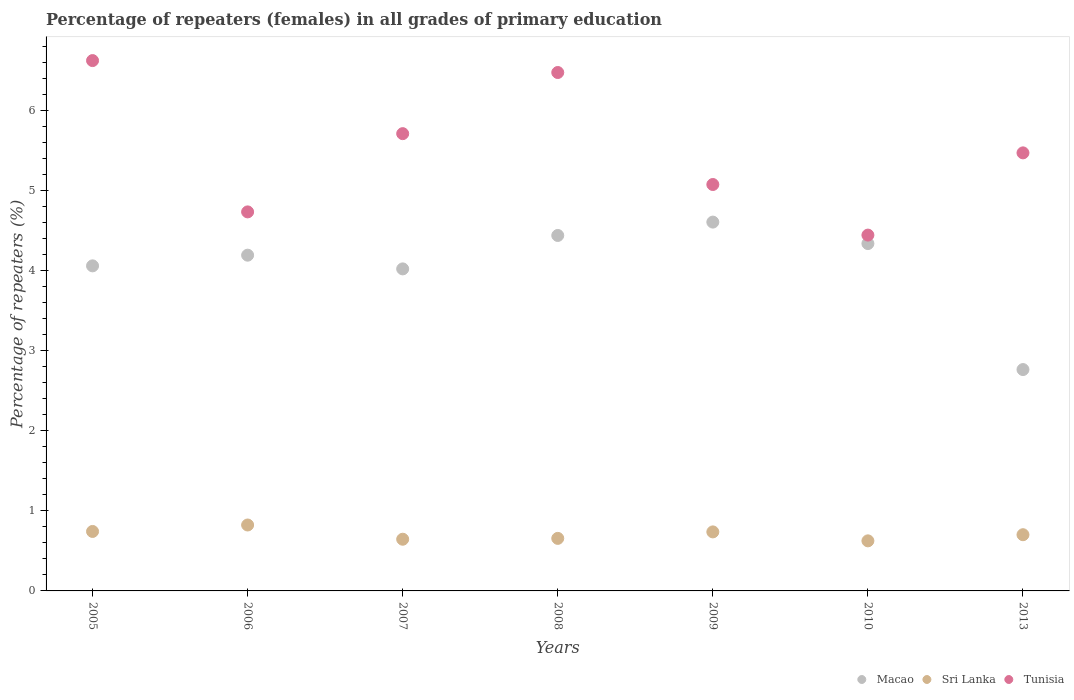Is the number of dotlines equal to the number of legend labels?
Make the answer very short. Yes. What is the percentage of repeaters (females) in Macao in 2010?
Keep it short and to the point. 4.34. Across all years, what is the maximum percentage of repeaters (females) in Tunisia?
Your answer should be very brief. 6.62. Across all years, what is the minimum percentage of repeaters (females) in Sri Lanka?
Your response must be concise. 0.63. In which year was the percentage of repeaters (females) in Tunisia minimum?
Give a very brief answer. 2010. What is the total percentage of repeaters (females) in Macao in the graph?
Offer a very short reply. 28.41. What is the difference between the percentage of repeaters (females) in Sri Lanka in 2005 and that in 2013?
Provide a succinct answer. 0.04. What is the difference between the percentage of repeaters (females) in Tunisia in 2013 and the percentage of repeaters (females) in Sri Lanka in 2007?
Your answer should be very brief. 4.82. What is the average percentage of repeaters (females) in Macao per year?
Keep it short and to the point. 4.06. In the year 2013, what is the difference between the percentage of repeaters (females) in Sri Lanka and percentage of repeaters (females) in Macao?
Your answer should be compact. -2.06. What is the ratio of the percentage of repeaters (females) in Sri Lanka in 2005 to that in 2009?
Provide a succinct answer. 1.01. What is the difference between the highest and the second highest percentage of repeaters (females) in Sri Lanka?
Your answer should be very brief. 0.08. What is the difference between the highest and the lowest percentage of repeaters (females) in Macao?
Give a very brief answer. 1.84. Is the sum of the percentage of repeaters (females) in Sri Lanka in 2006 and 2013 greater than the maximum percentage of repeaters (females) in Tunisia across all years?
Provide a short and direct response. No. Is it the case that in every year, the sum of the percentage of repeaters (females) in Sri Lanka and percentage of repeaters (females) in Macao  is greater than the percentage of repeaters (females) in Tunisia?
Offer a terse response. No. Does the percentage of repeaters (females) in Sri Lanka monotonically increase over the years?
Your answer should be very brief. No. Is the percentage of repeaters (females) in Macao strictly less than the percentage of repeaters (females) in Sri Lanka over the years?
Your response must be concise. No. How many years are there in the graph?
Keep it short and to the point. 7. What is the difference between two consecutive major ticks on the Y-axis?
Make the answer very short. 1. Are the values on the major ticks of Y-axis written in scientific E-notation?
Offer a very short reply. No. Does the graph contain any zero values?
Offer a terse response. No. Where does the legend appear in the graph?
Make the answer very short. Bottom right. How many legend labels are there?
Provide a succinct answer. 3. How are the legend labels stacked?
Keep it short and to the point. Horizontal. What is the title of the graph?
Offer a very short reply. Percentage of repeaters (females) in all grades of primary education. What is the label or title of the Y-axis?
Make the answer very short. Percentage of repeaters (%). What is the Percentage of repeaters (%) of Macao in 2005?
Your answer should be very brief. 4.06. What is the Percentage of repeaters (%) of Sri Lanka in 2005?
Give a very brief answer. 0.74. What is the Percentage of repeaters (%) of Tunisia in 2005?
Your answer should be very brief. 6.62. What is the Percentage of repeaters (%) of Macao in 2006?
Your answer should be very brief. 4.19. What is the Percentage of repeaters (%) in Sri Lanka in 2006?
Give a very brief answer. 0.82. What is the Percentage of repeaters (%) of Tunisia in 2006?
Your answer should be very brief. 4.73. What is the Percentage of repeaters (%) of Macao in 2007?
Give a very brief answer. 4.02. What is the Percentage of repeaters (%) in Sri Lanka in 2007?
Provide a succinct answer. 0.65. What is the Percentage of repeaters (%) of Tunisia in 2007?
Your response must be concise. 5.71. What is the Percentage of repeaters (%) of Macao in 2008?
Keep it short and to the point. 4.44. What is the Percentage of repeaters (%) in Sri Lanka in 2008?
Ensure brevity in your answer.  0.66. What is the Percentage of repeaters (%) in Tunisia in 2008?
Your response must be concise. 6.47. What is the Percentage of repeaters (%) in Macao in 2009?
Keep it short and to the point. 4.6. What is the Percentage of repeaters (%) of Sri Lanka in 2009?
Offer a very short reply. 0.74. What is the Percentage of repeaters (%) in Tunisia in 2009?
Offer a terse response. 5.07. What is the Percentage of repeaters (%) in Macao in 2010?
Your answer should be compact. 4.34. What is the Percentage of repeaters (%) of Sri Lanka in 2010?
Offer a terse response. 0.63. What is the Percentage of repeaters (%) of Tunisia in 2010?
Offer a terse response. 4.44. What is the Percentage of repeaters (%) in Macao in 2013?
Offer a very short reply. 2.76. What is the Percentage of repeaters (%) of Sri Lanka in 2013?
Your answer should be very brief. 0.7. What is the Percentage of repeaters (%) in Tunisia in 2013?
Provide a short and direct response. 5.47. Across all years, what is the maximum Percentage of repeaters (%) of Macao?
Your answer should be compact. 4.6. Across all years, what is the maximum Percentage of repeaters (%) in Sri Lanka?
Keep it short and to the point. 0.82. Across all years, what is the maximum Percentage of repeaters (%) of Tunisia?
Offer a very short reply. 6.62. Across all years, what is the minimum Percentage of repeaters (%) in Macao?
Provide a short and direct response. 2.76. Across all years, what is the minimum Percentage of repeaters (%) in Sri Lanka?
Give a very brief answer. 0.63. Across all years, what is the minimum Percentage of repeaters (%) of Tunisia?
Your response must be concise. 4.44. What is the total Percentage of repeaters (%) of Macao in the graph?
Make the answer very short. 28.41. What is the total Percentage of repeaters (%) of Sri Lanka in the graph?
Your response must be concise. 4.93. What is the total Percentage of repeaters (%) in Tunisia in the graph?
Provide a succinct answer. 38.52. What is the difference between the Percentage of repeaters (%) of Macao in 2005 and that in 2006?
Make the answer very short. -0.13. What is the difference between the Percentage of repeaters (%) of Sri Lanka in 2005 and that in 2006?
Offer a very short reply. -0.08. What is the difference between the Percentage of repeaters (%) in Tunisia in 2005 and that in 2006?
Your answer should be very brief. 1.89. What is the difference between the Percentage of repeaters (%) of Macao in 2005 and that in 2007?
Offer a very short reply. 0.04. What is the difference between the Percentage of repeaters (%) of Sri Lanka in 2005 and that in 2007?
Give a very brief answer. 0.1. What is the difference between the Percentage of repeaters (%) in Tunisia in 2005 and that in 2007?
Offer a terse response. 0.91. What is the difference between the Percentage of repeaters (%) of Macao in 2005 and that in 2008?
Your answer should be very brief. -0.38. What is the difference between the Percentage of repeaters (%) of Sri Lanka in 2005 and that in 2008?
Offer a terse response. 0.09. What is the difference between the Percentage of repeaters (%) in Tunisia in 2005 and that in 2008?
Your answer should be very brief. 0.15. What is the difference between the Percentage of repeaters (%) of Macao in 2005 and that in 2009?
Offer a terse response. -0.55. What is the difference between the Percentage of repeaters (%) of Sri Lanka in 2005 and that in 2009?
Your response must be concise. 0.01. What is the difference between the Percentage of repeaters (%) in Tunisia in 2005 and that in 2009?
Make the answer very short. 1.55. What is the difference between the Percentage of repeaters (%) in Macao in 2005 and that in 2010?
Your answer should be very brief. -0.28. What is the difference between the Percentage of repeaters (%) in Sri Lanka in 2005 and that in 2010?
Offer a terse response. 0.12. What is the difference between the Percentage of repeaters (%) of Tunisia in 2005 and that in 2010?
Your answer should be compact. 2.18. What is the difference between the Percentage of repeaters (%) of Macao in 2005 and that in 2013?
Provide a succinct answer. 1.29. What is the difference between the Percentage of repeaters (%) of Sri Lanka in 2005 and that in 2013?
Give a very brief answer. 0.04. What is the difference between the Percentage of repeaters (%) of Tunisia in 2005 and that in 2013?
Keep it short and to the point. 1.15. What is the difference between the Percentage of repeaters (%) of Macao in 2006 and that in 2007?
Your answer should be very brief. 0.17. What is the difference between the Percentage of repeaters (%) in Sri Lanka in 2006 and that in 2007?
Provide a succinct answer. 0.18. What is the difference between the Percentage of repeaters (%) in Tunisia in 2006 and that in 2007?
Offer a very short reply. -0.98. What is the difference between the Percentage of repeaters (%) in Macao in 2006 and that in 2008?
Ensure brevity in your answer.  -0.25. What is the difference between the Percentage of repeaters (%) of Sri Lanka in 2006 and that in 2008?
Provide a short and direct response. 0.17. What is the difference between the Percentage of repeaters (%) in Tunisia in 2006 and that in 2008?
Provide a short and direct response. -1.74. What is the difference between the Percentage of repeaters (%) in Macao in 2006 and that in 2009?
Offer a very short reply. -0.41. What is the difference between the Percentage of repeaters (%) in Sri Lanka in 2006 and that in 2009?
Keep it short and to the point. 0.09. What is the difference between the Percentage of repeaters (%) of Tunisia in 2006 and that in 2009?
Give a very brief answer. -0.34. What is the difference between the Percentage of repeaters (%) of Macao in 2006 and that in 2010?
Provide a succinct answer. -0.14. What is the difference between the Percentage of repeaters (%) in Sri Lanka in 2006 and that in 2010?
Ensure brevity in your answer.  0.2. What is the difference between the Percentage of repeaters (%) of Tunisia in 2006 and that in 2010?
Ensure brevity in your answer.  0.29. What is the difference between the Percentage of repeaters (%) in Macao in 2006 and that in 2013?
Ensure brevity in your answer.  1.43. What is the difference between the Percentage of repeaters (%) in Sri Lanka in 2006 and that in 2013?
Keep it short and to the point. 0.12. What is the difference between the Percentage of repeaters (%) of Tunisia in 2006 and that in 2013?
Keep it short and to the point. -0.74. What is the difference between the Percentage of repeaters (%) of Macao in 2007 and that in 2008?
Give a very brief answer. -0.42. What is the difference between the Percentage of repeaters (%) in Sri Lanka in 2007 and that in 2008?
Your answer should be compact. -0.01. What is the difference between the Percentage of repeaters (%) of Tunisia in 2007 and that in 2008?
Ensure brevity in your answer.  -0.76. What is the difference between the Percentage of repeaters (%) in Macao in 2007 and that in 2009?
Give a very brief answer. -0.58. What is the difference between the Percentage of repeaters (%) in Sri Lanka in 2007 and that in 2009?
Offer a terse response. -0.09. What is the difference between the Percentage of repeaters (%) in Tunisia in 2007 and that in 2009?
Your response must be concise. 0.63. What is the difference between the Percentage of repeaters (%) in Macao in 2007 and that in 2010?
Make the answer very short. -0.32. What is the difference between the Percentage of repeaters (%) in Sri Lanka in 2007 and that in 2010?
Provide a short and direct response. 0.02. What is the difference between the Percentage of repeaters (%) of Tunisia in 2007 and that in 2010?
Make the answer very short. 1.27. What is the difference between the Percentage of repeaters (%) of Macao in 2007 and that in 2013?
Provide a succinct answer. 1.26. What is the difference between the Percentage of repeaters (%) of Sri Lanka in 2007 and that in 2013?
Your response must be concise. -0.06. What is the difference between the Percentage of repeaters (%) of Tunisia in 2007 and that in 2013?
Ensure brevity in your answer.  0.24. What is the difference between the Percentage of repeaters (%) in Macao in 2008 and that in 2009?
Keep it short and to the point. -0.17. What is the difference between the Percentage of repeaters (%) of Sri Lanka in 2008 and that in 2009?
Provide a short and direct response. -0.08. What is the difference between the Percentage of repeaters (%) of Tunisia in 2008 and that in 2009?
Your answer should be very brief. 1.4. What is the difference between the Percentage of repeaters (%) in Macao in 2008 and that in 2010?
Keep it short and to the point. 0.1. What is the difference between the Percentage of repeaters (%) of Sri Lanka in 2008 and that in 2010?
Offer a very short reply. 0.03. What is the difference between the Percentage of repeaters (%) of Tunisia in 2008 and that in 2010?
Offer a terse response. 2.03. What is the difference between the Percentage of repeaters (%) of Macao in 2008 and that in 2013?
Provide a succinct answer. 1.67. What is the difference between the Percentage of repeaters (%) in Sri Lanka in 2008 and that in 2013?
Your response must be concise. -0.05. What is the difference between the Percentage of repeaters (%) in Macao in 2009 and that in 2010?
Your response must be concise. 0.27. What is the difference between the Percentage of repeaters (%) in Sri Lanka in 2009 and that in 2010?
Your answer should be compact. 0.11. What is the difference between the Percentage of repeaters (%) of Tunisia in 2009 and that in 2010?
Offer a very short reply. 0.63. What is the difference between the Percentage of repeaters (%) in Macao in 2009 and that in 2013?
Provide a succinct answer. 1.84. What is the difference between the Percentage of repeaters (%) in Sri Lanka in 2009 and that in 2013?
Ensure brevity in your answer.  0.04. What is the difference between the Percentage of repeaters (%) in Tunisia in 2009 and that in 2013?
Your answer should be very brief. -0.4. What is the difference between the Percentage of repeaters (%) in Macao in 2010 and that in 2013?
Provide a short and direct response. 1.57. What is the difference between the Percentage of repeaters (%) of Sri Lanka in 2010 and that in 2013?
Your answer should be very brief. -0.08. What is the difference between the Percentage of repeaters (%) in Tunisia in 2010 and that in 2013?
Keep it short and to the point. -1.03. What is the difference between the Percentage of repeaters (%) in Macao in 2005 and the Percentage of repeaters (%) in Sri Lanka in 2006?
Offer a very short reply. 3.24. What is the difference between the Percentage of repeaters (%) of Macao in 2005 and the Percentage of repeaters (%) of Tunisia in 2006?
Provide a short and direct response. -0.67. What is the difference between the Percentage of repeaters (%) of Sri Lanka in 2005 and the Percentage of repeaters (%) of Tunisia in 2006?
Make the answer very short. -3.99. What is the difference between the Percentage of repeaters (%) in Macao in 2005 and the Percentage of repeaters (%) in Sri Lanka in 2007?
Your answer should be compact. 3.41. What is the difference between the Percentage of repeaters (%) of Macao in 2005 and the Percentage of repeaters (%) of Tunisia in 2007?
Provide a succinct answer. -1.65. What is the difference between the Percentage of repeaters (%) in Sri Lanka in 2005 and the Percentage of repeaters (%) in Tunisia in 2007?
Your answer should be very brief. -4.97. What is the difference between the Percentage of repeaters (%) of Macao in 2005 and the Percentage of repeaters (%) of Sri Lanka in 2008?
Offer a very short reply. 3.4. What is the difference between the Percentage of repeaters (%) in Macao in 2005 and the Percentage of repeaters (%) in Tunisia in 2008?
Give a very brief answer. -2.41. What is the difference between the Percentage of repeaters (%) of Sri Lanka in 2005 and the Percentage of repeaters (%) of Tunisia in 2008?
Keep it short and to the point. -5.73. What is the difference between the Percentage of repeaters (%) of Macao in 2005 and the Percentage of repeaters (%) of Sri Lanka in 2009?
Ensure brevity in your answer.  3.32. What is the difference between the Percentage of repeaters (%) of Macao in 2005 and the Percentage of repeaters (%) of Tunisia in 2009?
Offer a terse response. -1.02. What is the difference between the Percentage of repeaters (%) in Sri Lanka in 2005 and the Percentage of repeaters (%) in Tunisia in 2009?
Offer a very short reply. -4.33. What is the difference between the Percentage of repeaters (%) in Macao in 2005 and the Percentage of repeaters (%) in Sri Lanka in 2010?
Your response must be concise. 3.43. What is the difference between the Percentage of repeaters (%) in Macao in 2005 and the Percentage of repeaters (%) in Tunisia in 2010?
Ensure brevity in your answer.  -0.38. What is the difference between the Percentage of repeaters (%) in Sri Lanka in 2005 and the Percentage of repeaters (%) in Tunisia in 2010?
Provide a short and direct response. -3.7. What is the difference between the Percentage of repeaters (%) in Macao in 2005 and the Percentage of repeaters (%) in Sri Lanka in 2013?
Your answer should be compact. 3.36. What is the difference between the Percentage of repeaters (%) of Macao in 2005 and the Percentage of repeaters (%) of Tunisia in 2013?
Your response must be concise. -1.41. What is the difference between the Percentage of repeaters (%) in Sri Lanka in 2005 and the Percentage of repeaters (%) in Tunisia in 2013?
Keep it short and to the point. -4.73. What is the difference between the Percentage of repeaters (%) in Macao in 2006 and the Percentage of repeaters (%) in Sri Lanka in 2007?
Give a very brief answer. 3.55. What is the difference between the Percentage of repeaters (%) in Macao in 2006 and the Percentage of repeaters (%) in Tunisia in 2007?
Your response must be concise. -1.52. What is the difference between the Percentage of repeaters (%) in Sri Lanka in 2006 and the Percentage of repeaters (%) in Tunisia in 2007?
Keep it short and to the point. -4.89. What is the difference between the Percentage of repeaters (%) in Macao in 2006 and the Percentage of repeaters (%) in Sri Lanka in 2008?
Keep it short and to the point. 3.54. What is the difference between the Percentage of repeaters (%) in Macao in 2006 and the Percentage of repeaters (%) in Tunisia in 2008?
Keep it short and to the point. -2.28. What is the difference between the Percentage of repeaters (%) in Sri Lanka in 2006 and the Percentage of repeaters (%) in Tunisia in 2008?
Give a very brief answer. -5.65. What is the difference between the Percentage of repeaters (%) of Macao in 2006 and the Percentage of repeaters (%) of Sri Lanka in 2009?
Ensure brevity in your answer.  3.45. What is the difference between the Percentage of repeaters (%) in Macao in 2006 and the Percentage of repeaters (%) in Tunisia in 2009?
Offer a terse response. -0.88. What is the difference between the Percentage of repeaters (%) in Sri Lanka in 2006 and the Percentage of repeaters (%) in Tunisia in 2009?
Provide a short and direct response. -4.25. What is the difference between the Percentage of repeaters (%) in Macao in 2006 and the Percentage of repeaters (%) in Sri Lanka in 2010?
Offer a very short reply. 3.57. What is the difference between the Percentage of repeaters (%) of Macao in 2006 and the Percentage of repeaters (%) of Tunisia in 2010?
Give a very brief answer. -0.25. What is the difference between the Percentage of repeaters (%) in Sri Lanka in 2006 and the Percentage of repeaters (%) in Tunisia in 2010?
Offer a terse response. -3.62. What is the difference between the Percentage of repeaters (%) of Macao in 2006 and the Percentage of repeaters (%) of Sri Lanka in 2013?
Make the answer very short. 3.49. What is the difference between the Percentage of repeaters (%) of Macao in 2006 and the Percentage of repeaters (%) of Tunisia in 2013?
Your answer should be compact. -1.28. What is the difference between the Percentage of repeaters (%) of Sri Lanka in 2006 and the Percentage of repeaters (%) of Tunisia in 2013?
Offer a very short reply. -4.65. What is the difference between the Percentage of repeaters (%) of Macao in 2007 and the Percentage of repeaters (%) of Sri Lanka in 2008?
Make the answer very short. 3.36. What is the difference between the Percentage of repeaters (%) in Macao in 2007 and the Percentage of repeaters (%) in Tunisia in 2008?
Offer a very short reply. -2.45. What is the difference between the Percentage of repeaters (%) in Sri Lanka in 2007 and the Percentage of repeaters (%) in Tunisia in 2008?
Your response must be concise. -5.83. What is the difference between the Percentage of repeaters (%) in Macao in 2007 and the Percentage of repeaters (%) in Sri Lanka in 2009?
Your answer should be very brief. 3.28. What is the difference between the Percentage of repeaters (%) in Macao in 2007 and the Percentage of repeaters (%) in Tunisia in 2009?
Offer a very short reply. -1.05. What is the difference between the Percentage of repeaters (%) of Sri Lanka in 2007 and the Percentage of repeaters (%) of Tunisia in 2009?
Your response must be concise. -4.43. What is the difference between the Percentage of repeaters (%) of Macao in 2007 and the Percentage of repeaters (%) of Sri Lanka in 2010?
Offer a very short reply. 3.4. What is the difference between the Percentage of repeaters (%) of Macao in 2007 and the Percentage of repeaters (%) of Tunisia in 2010?
Keep it short and to the point. -0.42. What is the difference between the Percentage of repeaters (%) of Sri Lanka in 2007 and the Percentage of repeaters (%) of Tunisia in 2010?
Your response must be concise. -3.8. What is the difference between the Percentage of repeaters (%) of Macao in 2007 and the Percentage of repeaters (%) of Sri Lanka in 2013?
Your response must be concise. 3.32. What is the difference between the Percentage of repeaters (%) of Macao in 2007 and the Percentage of repeaters (%) of Tunisia in 2013?
Offer a very short reply. -1.45. What is the difference between the Percentage of repeaters (%) of Sri Lanka in 2007 and the Percentage of repeaters (%) of Tunisia in 2013?
Make the answer very short. -4.82. What is the difference between the Percentage of repeaters (%) of Macao in 2008 and the Percentage of repeaters (%) of Sri Lanka in 2009?
Your response must be concise. 3.7. What is the difference between the Percentage of repeaters (%) in Macao in 2008 and the Percentage of repeaters (%) in Tunisia in 2009?
Offer a very short reply. -0.64. What is the difference between the Percentage of repeaters (%) in Sri Lanka in 2008 and the Percentage of repeaters (%) in Tunisia in 2009?
Your answer should be compact. -4.42. What is the difference between the Percentage of repeaters (%) in Macao in 2008 and the Percentage of repeaters (%) in Sri Lanka in 2010?
Your response must be concise. 3.81. What is the difference between the Percentage of repeaters (%) of Macao in 2008 and the Percentage of repeaters (%) of Tunisia in 2010?
Make the answer very short. -0. What is the difference between the Percentage of repeaters (%) in Sri Lanka in 2008 and the Percentage of repeaters (%) in Tunisia in 2010?
Provide a short and direct response. -3.79. What is the difference between the Percentage of repeaters (%) in Macao in 2008 and the Percentage of repeaters (%) in Sri Lanka in 2013?
Make the answer very short. 3.74. What is the difference between the Percentage of repeaters (%) in Macao in 2008 and the Percentage of repeaters (%) in Tunisia in 2013?
Make the answer very short. -1.03. What is the difference between the Percentage of repeaters (%) of Sri Lanka in 2008 and the Percentage of repeaters (%) of Tunisia in 2013?
Offer a very short reply. -4.81. What is the difference between the Percentage of repeaters (%) of Macao in 2009 and the Percentage of repeaters (%) of Sri Lanka in 2010?
Your response must be concise. 3.98. What is the difference between the Percentage of repeaters (%) in Macao in 2009 and the Percentage of repeaters (%) in Tunisia in 2010?
Give a very brief answer. 0.16. What is the difference between the Percentage of repeaters (%) in Sri Lanka in 2009 and the Percentage of repeaters (%) in Tunisia in 2010?
Offer a very short reply. -3.71. What is the difference between the Percentage of repeaters (%) of Macao in 2009 and the Percentage of repeaters (%) of Sri Lanka in 2013?
Make the answer very short. 3.9. What is the difference between the Percentage of repeaters (%) in Macao in 2009 and the Percentage of repeaters (%) in Tunisia in 2013?
Your answer should be compact. -0.86. What is the difference between the Percentage of repeaters (%) of Sri Lanka in 2009 and the Percentage of repeaters (%) of Tunisia in 2013?
Offer a very short reply. -4.73. What is the difference between the Percentage of repeaters (%) of Macao in 2010 and the Percentage of repeaters (%) of Sri Lanka in 2013?
Your response must be concise. 3.63. What is the difference between the Percentage of repeaters (%) of Macao in 2010 and the Percentage of repeaters (%) of Tunisia in 2013?
Provide a short and direct response. -1.13. What is the difference between the Percentage of repeaters (%) of Sri Lanka in 2010 and the Percentage of repeaters (%) of Tunisia in 2013?
Make the answer very short. -4.84. What is the average Percentage of repeaters (%) in Macao per year?
Offer a terse response. 4.06. What is the average Percentage of repeaters (%) in Sri Lanka per year?
Provide a succinct answer. 0.7. What is the average Percentage of repeaters (%) in Tunisia per year?
Give a very brief answer. 5.5. In the year 2005, what is the difference between the Percentage of repeaters (%) of Macao and Percentage of repeaters (%) of Sri Lanka?
Your answer should be compact. 3.32. In the year 2005, what is the difference between the Percentage of repeaters (%) of Macao and Percentage of repeaters (%) of Tunisia?
Your answer should be very brief. -2.56. In the year 2005, what is the difference between the Percentage of repeaters (%) of Sri Lanka and Percentage of repeaters (%) of Tunisia?
Offer a terse response. -5.88. In the year 2006, what is the difference between the Percentage of repeaters (%) of Macao and Percentage of repeaters (%) of Sri Lanka?
Offer a terse response. 3.37. In the year 2006, what is the difference between the Percentage of repeaters (%) of Macao and Percentage of repeaters (%) of Tunisia?
Provide a succinct answer. -0.54. In the year 2006, what is the difference between the Percentage of repeaters (%) of Sri Lanka and Percentage of repeaters (%) of Tunisia?
Provide a short and direct response. -3.91. In the year 2007, what is the difference between the Percentage of repeaters (%) in Macao and Percentage of repeaters (%) in Sri Lanka?
Provide a short and direct response. 3.37. In the year 2007, what is the difference between the Percentage of repeaters (%) in Macao and Percentage of repeaters (%) in Tunisia?
Offer a terse response. -1.69. In the year 2007, what is the difference between the Percentage of repeaters (%) of Sri Lanka and Percentage of repeaters (%) of Tunisia?
Keep it short and to the point. -5.06. In the year 2008, what is the difference between the Percentage of repeaters (%) of Macao and Percentage of repeaters (%) of Sri Lanka?
Provide a succinct answer. 3.78. In the year 2008, what is the difference between the Percentage of repeaters (%) of Macao and Percentage of repeaters (%) of Tunisia?
Give a very brief answer. -2.03. In the year 2008, what is the difference between the Percentage of repeaters (%) of Sri Lanka and Percentage of repeaters (%) of Tunisia?
Give a very brief answer. -5.82. In the year 2009, what is the difference between the Percentage of repeaters (%) of Macao and Percentage of repeaters (%) of Sri Lanka?
Offer a very short reply. 3.87. In the year 2009, what is the difference between the Percentage of repeaters (%) of Macao and Percentage of repeaters (%) of Tunisia?
Give a very brief answer. -0.47. In the year 2009, what is the difference between the Percentage of repeaters (%) in Sri Lanka and Percentage of repeaters (%) in Tunisia?
Keep it short and to the point. -4.34. In the year 2010, what is the difference between the Percentage of repeaters (%) in Macao and Percentage of repeaters (%) in Sri Lanka?
Your answer should be very brief. 3.71. In the year 2010, what is the difference between the Percentage of repeaters (%) in Macao and Percentage of repeaters (%) in Tunisia?
Your response must be concise. -0.11. In the year 2010, what is the difference between the Percentage of repeaters (%) in Sri Lanka and Percentage of repeaters (%) in Tunisia?
Make the answer very short. -3.82. In the year 2013, what is the difference between the Percentage of repeaters (%) of Macao and Percentage of repeaters (%) of Sri Lanka?
Provide a short and direct response. 2.06. In the year 2013, what is the difference between the Percentage of repeaters (%) of Macao and Percentage of repeaters (%) of Tunisia?
Offer a terse response. -2.71. In the year 2013, what is the difference between the Percentage of repeaters (%) in Sri Lanka and Percentage of repeaters (%) in Tunisia?
Your answer should be compact. -4.77. What is the ratio of the Percentage of repeaters (%) in Macao in 2005 to that in 2006?
Give a very brief answer. 0.97. What is the ratio of the Percentage of repeaters (%) of Sri Lanka in 2005 to that in 2006?
Your answer should be compact. 0.9. What is the ratio of the Percentage of repeaters (%) in Tunisia in 2005 to that in 2006?
Your response must be concise. 1.4. What is the ratio of the Percentage of repeaters (%) in Macao in 2005 to that in 2007?
Ensure brevity in your answer.  1.01. What is the ratio of the Percentage of repeaters (%) of Sri Lanka in 2005 to that in 2007?
Offer a terse response. 1.15. What is the ratio of the Percentage of repeaters (%) of Tunisia in 2005 to that in 2007?
Your answer should be compact. 1.16. What is the ratio of the Percentage of repeaters (%) of Macao in 2005 to that in 2008?
Give a very brief answer. 0.91. What is the ratio of the Percentage of repeaters (%) in Sri Lanka in 2005 to that in 2008?
Your answer should be very brief. 1.13. What is the ratio of the Percentage of repeaters (%) of Macao in 2005 to that in 2009?
Provide a succinct answer. 0.88. What is the ratio of the Percentage of repeaters (%) of Sri Lanka in 2005 to that in 2009?
Give a very brief answer. 1.01. What is the ratio of the Percentage of repeaters (%) in Tunisia in 2005 to that in 2009?
Make the answer very short. 1.3. What is the ratio of the Percentage of repeaters (%) in Macao in 2005 to that in 2010?
Offer a terse response. 0.94. What is the ratio of the Percentage of repeaters (%) in Sri Lanka in 2005 to that in 2010?
Offer a terse response. 1.19. What is the ratio of the Percentage of repeaters (%) in Tunisia in 2005 to that in 2010?
Keep it short and to the point. 1.49. What is the ratio of the Percentage of repeaters (%) of Macao in 2005 to that in 2013?
Keep it short and to the point. 1.47. What is the ratio of the Percentage of repeaters (%) in Sri Lanka in 2005 to that in 2013?
Offer a very short reply. 1.06. What is the ratio of the Percentage of repeaters (%) of Tunisia in 2005 to that in 2013?
Your response must be concise. 1.21. What is the ratio of the Percentage of repeaters (%) of Macao in 2006 to that in 2007?
Offer a terse response. 1.04. What is the ratio of the Percentage of repeaters (%) of Sri Lanka in 2006 to that in 2007?
Offer a terse response. 1.28. What is the ratio of the Percentage of repeaters (%) of Tunisia in 2006 to that in 2007?
Ensure brevity in your answer.  0.83. What is the ratio of the Percentage of repeaters (%) of Macao in 2006 to that in 2008?
Keep it short and to the point. 0.94. What is the ratio of the Percentage of repeaters (%) of Sri Lanka in 2006 to that in 2008?
Ensure brevity in your answer.  1.25. What is the ratio of the Percentage of repeaters (%) in Tunisia in 2006 to that in 2008?
Provide a short and direct response. 0.73. What is the ratio of the Percentage of repeaters (%) of Macao in 2006 to that in 2009?
Make the answer very short. 0.91. What is the ratio of the Percentage of repeaters (%) in Sri Lanka in 2006 to that in 2009?
Provide a short and direct response. 1.12. What is the ratio of the Percentage of repeaters (%) in Tunisia in 2006 to that in 2009?
Provide a succinct answer. 0.93. What is the ratio of the Percentage of repeaters (%) of Macao in 2006 to that in 2010?
Provide a succinct answer. 0.97. What is the ratio of the Percentage of repeaters (%) of Sri Lanka in 2006 to that in 2010?
Offer a very short reply. 1.32. What is the ratio of the Percentage of repeaters (%) in Tunisia in 2006 to that in 2010?
Your response must be concise. 1.07. What is the ratio of the Percentage of repeaters (%) of Macao in 2006 to that in 2013?
Your answer should be very brief. 1.52. What is the ratio of the Percentage of repeaters (%) in Sri Lanka in 2006 to that in 2013?
Offer a very short reply. 1.17. What is the ratio of the Percentage of repeaters (%) of Tunisia in 2006 to that in 2013?
Your answer should be very brief. 0.87. What is the ratio of the Percentage of repeaters (%) of Macao in 2007 to that in 2008?
Ensure brevity in your answer.  0.91. What is the ratio of the Percentage of repeaters (%) of Sri Lanka in 2007 to that in 2008?
Your answer should be very brief. 0.98. What is the ratio of the Percentage of repeaters (%) in Tunisia in 2007 to that in 2008?
Provide a short and direct response. 0.88. What is the ratio of the Percentage of repeaters (%) of Macao in 2007 to that in 2009?
Keep it short and to the point. 0.87. What is the ratio of the Percentage of repeaters (%) in Sri Lanka in 2007 to that in 2009?
Offer a very short reply. 0.88. What is the ratio of the Percentage of repeaters (%) in Tunisia in 2007 to that in 2009?
Offer a very short reply. 1.13. What is the ratio of the Percentage of repeaters (%) of Macao in 2007 to that in 2010?
Give a very brief answer. 0.93. What is the ratio of the Percentage of repeaters (%) of Sri Lanka in 2007 to that in 2010?
Your answer should be very brief. 1.03. What is the ratio of the Percentage of repeaters (%) of Tunisia in 2007 to that in 2010?
Your answer should be very brief. 1.29. What is the ratio of the Percentage of repeaters (%) of Macao in 2007 to that in 2013?
Keep it short and to the point. 1.45. What is the ratio of the Percentage of repeaters (%) of Sri Lanka in 2007 to that in 2013?
Offer a very short reply. 0.92. What is the ratio of the Percentage of repeaters (%) of Tunisia in 2007 to that in 2013?
Your answer should be compact. 1.04. What is the ratio of the Percentage of repeaters (%) in Macao in 2008 to that in 2009?
Provide a succinct answer. 0.96. What is the ratio of the Percentage of repeaters (%) of Sri Lanka in 2008 to that in 2009?
Offer a very short reply. 0.89. What is the ratio of the Percentage of repeaters (%) in Tunisia in 2008 to that in 2009?
Your answer should be compact. 1.28. What is the ratio of the Percentage of repeaters (%) of Macao in 2008 to that in 2010?
Offer a terse response. 1.02. What is the ratio of the Percentage of repeaters (%) of Sri Lanka in 2008 to that in 2010?
Your answer should be compact. 1.05. What is the ratio of the Percentage of repeaters (%) of Tunisia in 2008 to that in 2010?
Provide a succinct answer. 1.46. What is the ratio of the Percentage of repeaters (%) of Macao in 2008 to that in 2013?
Offer a very short reply. 1.61. What is the ratio of the Percentage of repeaters (%) in Sri Lanka in 2008 to that in 2013?
Keep it short and to the point. 0.93. What is the ratio of the Percentage of repeaters (%) of Tunisia in 2008 to that in 2013?
Offer a very short reply. 1.18. What is the ratio of the Percentage of repeaters (%) of Macao in 2009 to that in 2010?
Your answer should be compact. 1.06. What is the ratio of the Percentage of repeaters (%) of Sri Lanka in 2009 to that in 2010?
Your answer should be very brief. 1.18. What is the ratio of the Percentage of repeaters (%) in Tunisia in 2009 to that in 2010?
Offer a very short reply. 1.14. What is the ratio of the Percentage of repeaters (%) in Macao in 2009 to that in 2013?
Ensure brevity in your answer.  1.67. What is the ratio of the Percentage of repeaters (%) in Sri Lanka in 2009 to that in 2013?
Provide a short and direct response. 1.05. What is the ratio of the Percentage of repeaters (%) in Tunisia in 2009 to that in 2013?
Keep it short and to the point. 0.93. What is the ratio of the Percentage of repeaters (%) of Macao in 2010 to that in 2013?
Provide a succinct answer. 1.57. What is the ratio of the Percentage of repeaters (%) in Sri Lanka in 2010 to that in 2013?
Your response must be concise. 0.89. What is the ratio of the Percentage of repeaters (%) of Tunisia in 2010 to that in 2013?
Your answer should be compact. 0.81. What is the difference between the highest and the second highest Percentage of repeaters (%) of Macao?
Make the answer very short. 0.17. What is the difference between the highest and the second highest Percentage of repeaters (%) in Sri Lanka?
Provide a succinct answer. 0.08. What is the difference between the highest and the second highest Percentage of repeaters (%) of Tunisia?
Your answer should be compact. 0.15. What is the difference between the highest and the lowest Percentage of repeaters (%) of Macao?
Keep it short and to the point. 1.84. What is the difference between the highest and the lowest Percentage of repeaters (%) in Sri Lanka?
Your answer should be compact. 0.2. What is the difference between the highest and the lowest Percentage of repeaters (%) in Tunisia?
Provide a short and direct response. 2.18. 